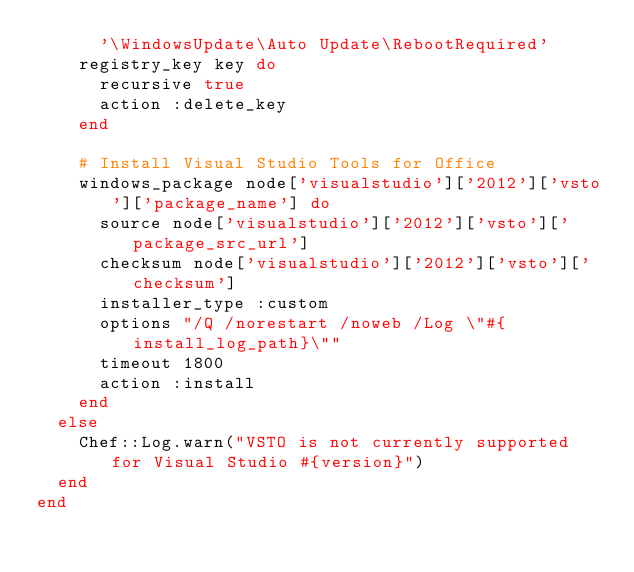Convert code to text. <code><loc_0><loc_0><loc_500><loc_500><_Ruby_>      '\WindowsUpdate\Auto Update\RebootRequired'
    registry_key key do
      recursive true
      action :delete_key
    end

    # Install Visual Studio Tools for Office
    windows_package node['visualstudio']['2012']['vsto']['package_name'] do
      source node['visualstudio']['2012']['vsto']['package_src_url']
      checksum node['visualstudio']['2012']['vsto']['checksum']
      installer_type :custom
      options "/Q /norestart /noweb /Log \"#{install_log_path}\""
      timeout 1800
      action :install
    end
  else
    Chef::Log.warn("VSTO is not currently supported for Visual Studio #{version}")
  end
end
</code> 